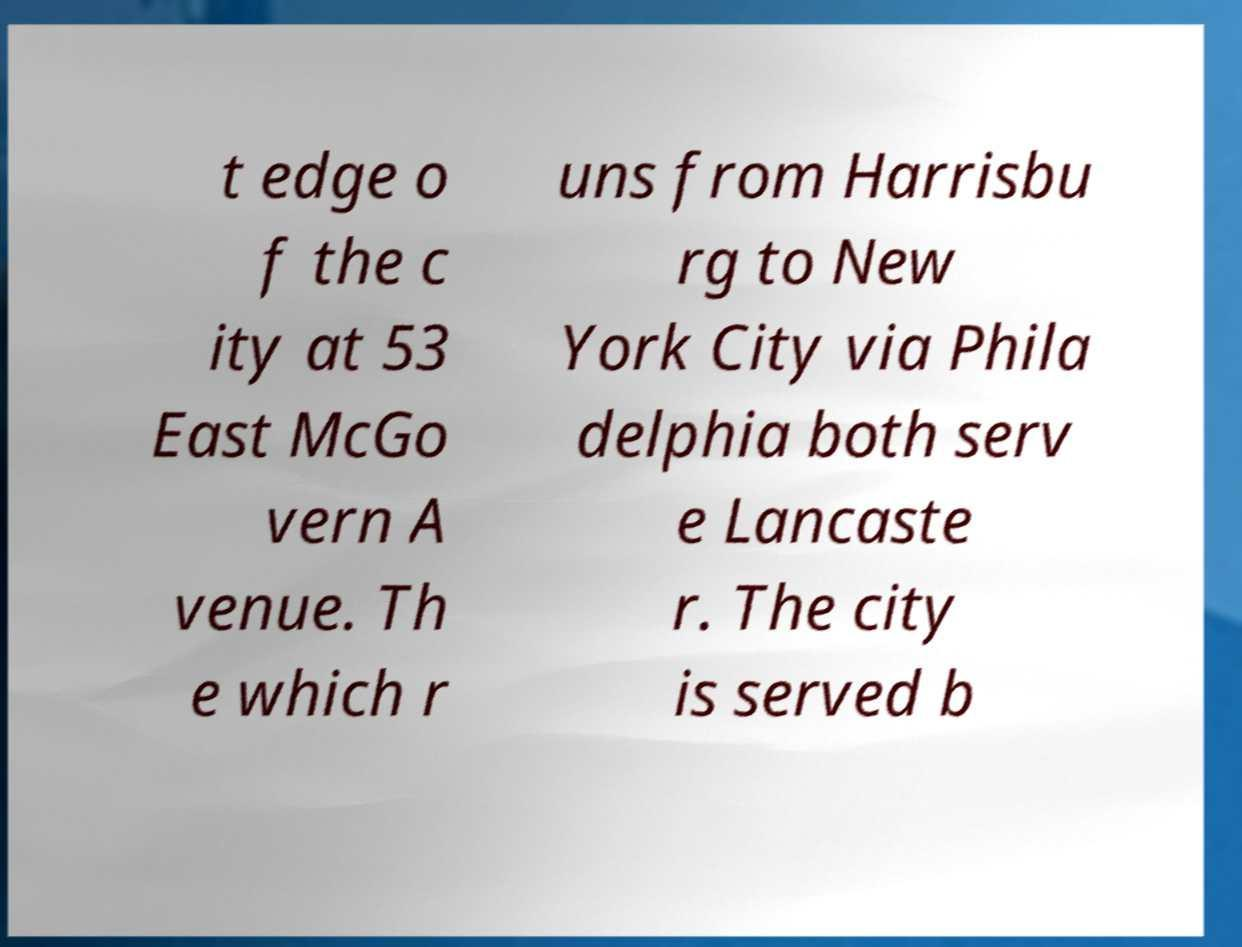Please read and relay the text visible in this image. What does it say? t edge o f the c ity at 53 East McGo vern A venue. Th e which r uns from Harrisbu rg to New York City via Phila delphia both serv e Lancaste r. The city is served b 